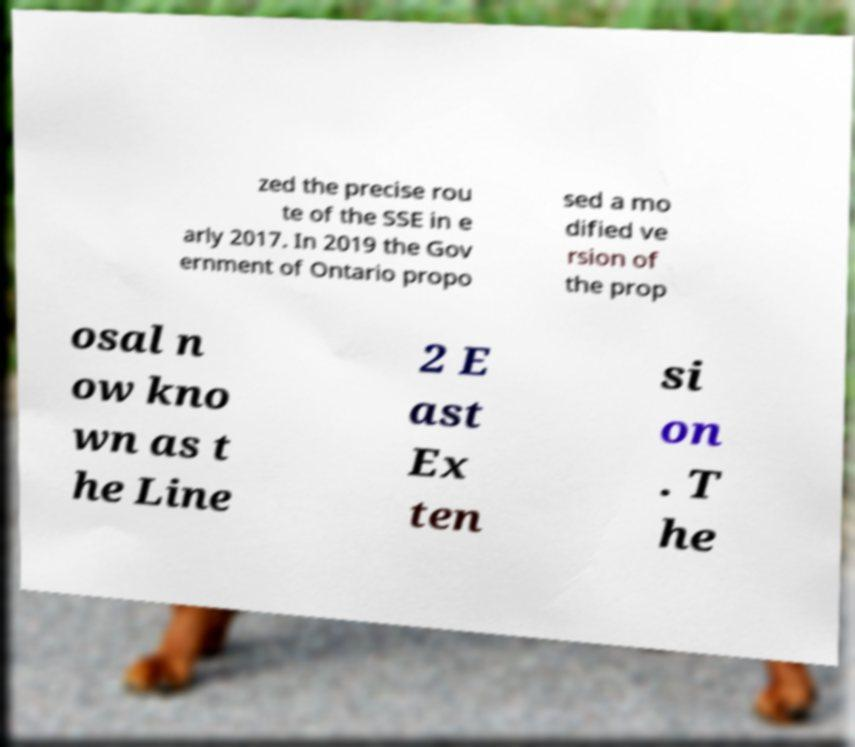For documentation purposes, I need the text within this image transcribed. Could you provide that? zed the precise rou te of the SSE in e arly 2017. In 2019 the Gov ernment of Ontario propo sed a mo dified ve rsion of the prop osal n ow kno wn as t he Line 2 E ast Ex ten si on . T he 